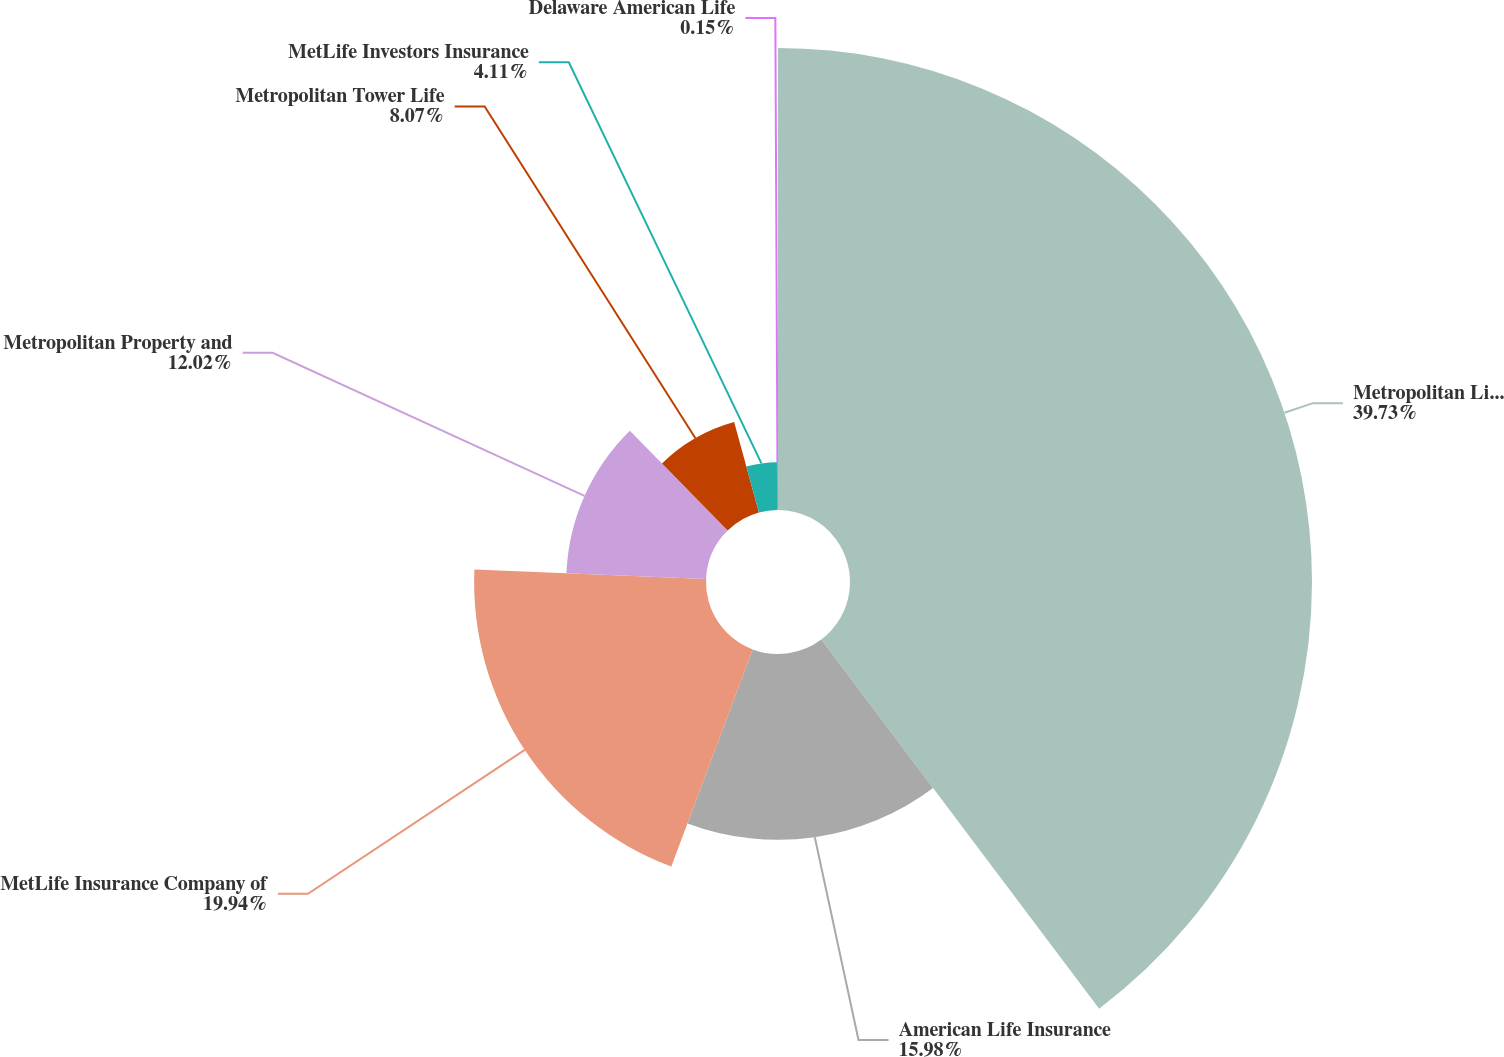Convert chart. <chart><loc_0><loc_0><loc_500><loc_500><pie_chart><fcel>Metropolitan Life Insurance<fcel>American Life Insurance<fcel>MetLife Insurance Company of<fcel>Metropolitan Property and<fcel>Metropolitan Tower Life<fcel>MetLife Investors Insurance<fcel>Delaware American Life<nl><fcel>39.73%<fcel>15.98%<fcel>19.94%<fcel>12.02%<fcel>8.07%<fcel>4.11%<fcel>0.15%<nl></chart> 